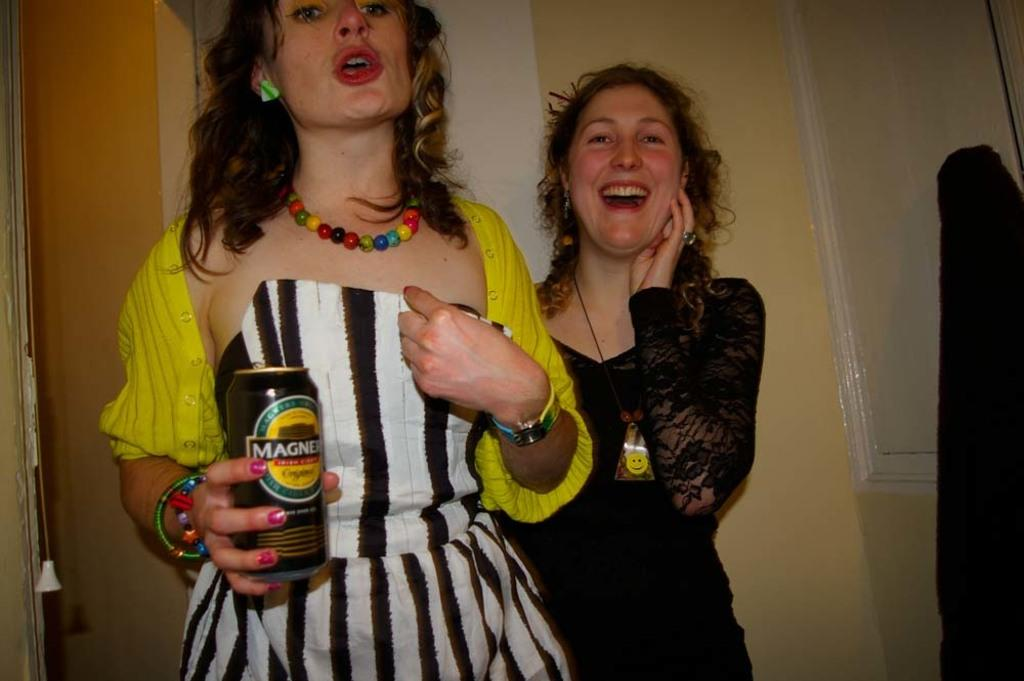How many people are present in the image? There are two women in the image. What is one of the women holding in her hand? One of the women is holding a tin in her hand. What can be seen in the background of the image? There is a wall in the background of the image. What type of machine is being used by the women to play volleyball in the image? There is no machine or volleyball present in the image; it features two women and a tin. 